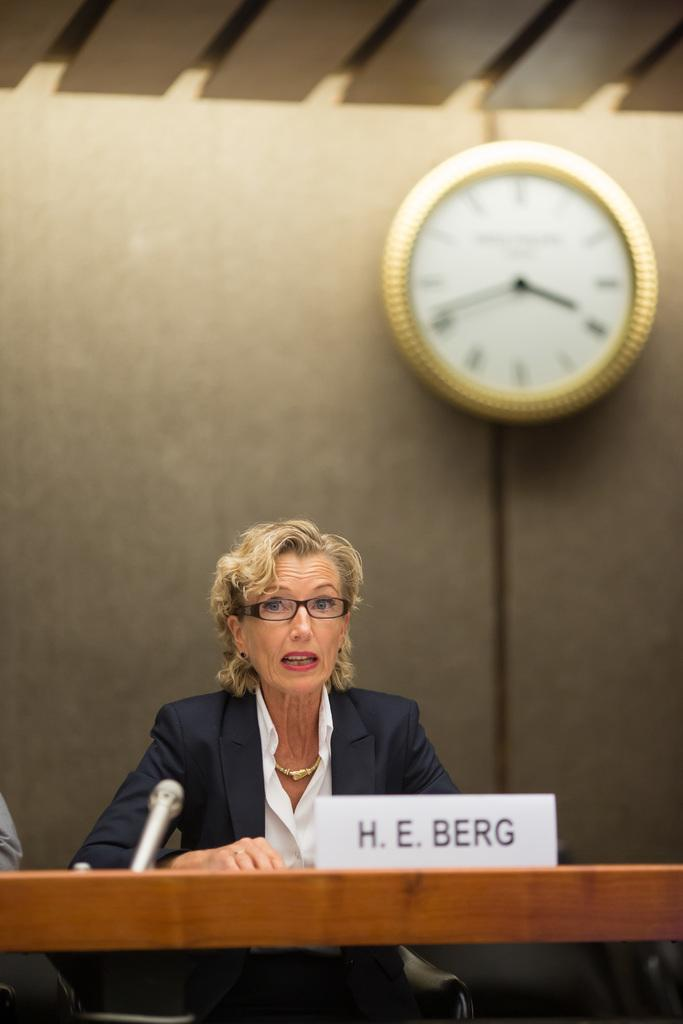<image>
Describe the image concisely. A woman sitting in front of a microphone and the words H E Berg in front of her. 